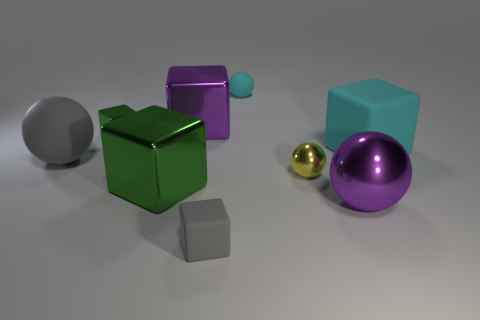Which objects in the image are metallic? In the image, there are two metallic objects: one small golden sphere and one larger purple sphere. The rest of the objects appear to have matte surfaces. 